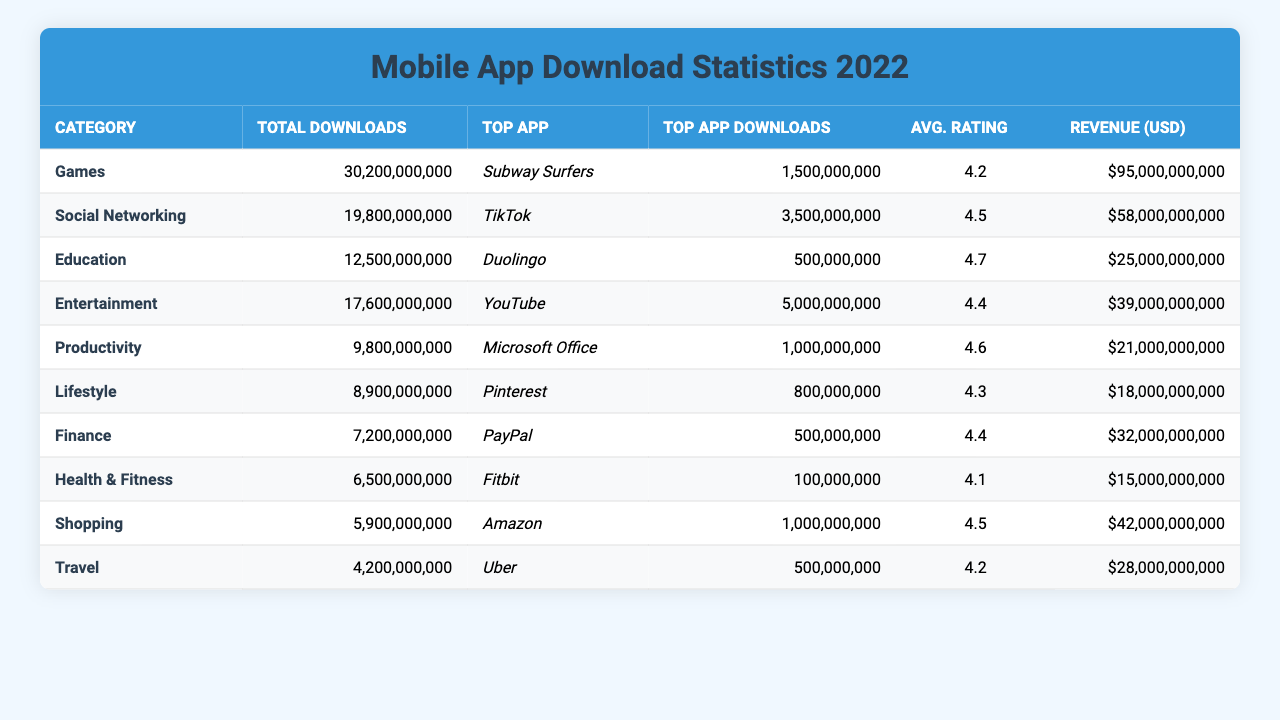What category has the highest total downloads? By examining the total downloads column, "Games" shows the highest number, with 30,200,000,000 downloads.
Answer: Games Which app has the most downloads in the Social Networking category? The top app under Social Networking is "TikTok," which has 3,500,000,000 downloads.
Answer: TikTok What is the average rating of the Education category? The average rating for the Education category can be found directly in the table and is listed as 4.7.
Answer: 4.7 How many total downloads do the top three categories have combined? Adding "Games" (30,200,000,000), "Social Networking" (19,800,000,000), and "Entertainment" (17,600,000,000) gives a total of 30,200,000,000 + 19,800,000,000 + 17,600,000,000 = 67,600,000,000.
Answer: 67,600,000,000 Is the average rating of the Finance category higher than that of Health & Fitness? The Finance category has an average rating of 4.4, while Health & Fitness has an average rating of 4.1, making Finance's rating higher.
Answer: Yes Which category has the lowest revenue in USD, and what is the amount? "Health & Fitness" has the lowest revenue of 15,000,000,000 USD among all the categories listed.
Answer: 15,000,000,000 What is the difference in total downloads between the Games and Travel categories? The total downloads for Games is 30,200,000,000 and for Travel is 4,200,000,000. The difference is 30,200,000,000 - 4,200,000,000 = 26,000,000,000.
Answer: 26,000,000,000 Which top app has a higher number of downloads, "Duolingo" or "Fitbit"? Comparing the downloads, "Duolingo" has 500,000,000 downloads and "Fitbit" has 100,000 downloads, making "Duolingo" higher.
Answer: Duolingo What percentage of total downloads does the highest revenue category, Social Networking, represent? Social Networking has total downloads of 19,800,000,000. The total downloads from all categories sum to 67,600,000,000. The percentage is (19,800,000,000 / 67,600,000,000) * 100 = 29.3%.
Answer: 29.3% Is there any category that has an average rating of 4.5? Yes, both the Social Networking and Shopping categories have an average rating of 4.5.
Answer: Yes 